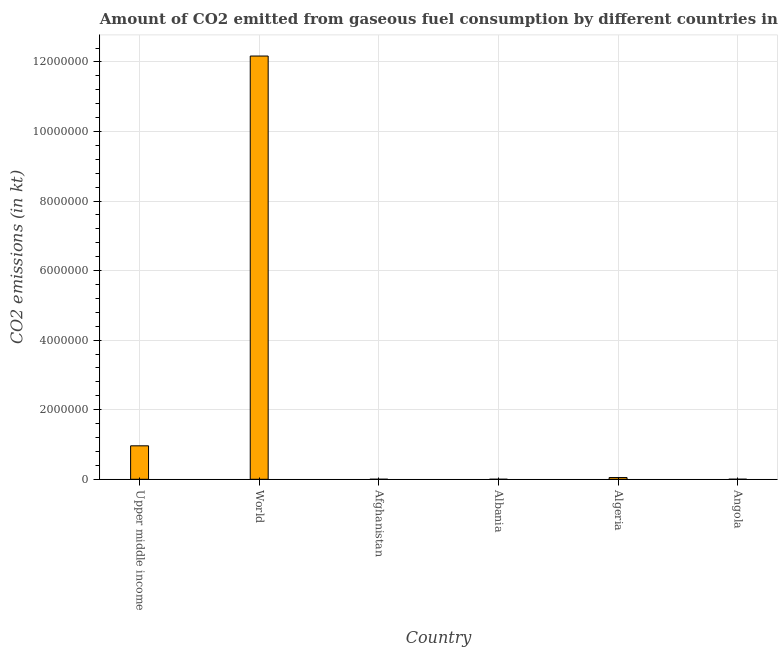Does the graph contain any zero values?
Keep it short and to the point. No. What is the title of the graph?
Provide a succinct answer. Amount of CO2 emitted from gaseous fuel consumption by different countries in 2006. What is the label or title of the X-axis?
Make the answer very short. Country. What is the label or title of the Y-axis?
Your answer should be compact. CO2 emissions (in kt). What is the co2 emissions from gaseous fuel consumption in Albania?
Make the answer very short. 22. Across all countries, what is the maximum co2 emissions from gaseous fuel consumption?
Your answer should be compact. 1.22e+07. Across all countries, what is the minimum co2 emissions from gaseous fuel consumption?
Keep it short and to the point. 22. In which country was the co2 emissions from gaseous fuel consumption maximum?
Provide a succinct answer. World. In which country was the co2 emissions from gaseous fuel consumption minimum?
Your response must be concise. Albania. What is the sum of the co2 emissions from gaseous fuel consumption?
Offer a terse response. 1.32e+07. What is the difference between the co2 emissions from gaseous fuel consumption in Angola and World?
Keep it short and to the point. -1.22e+07. What is the average co2 emissions from gaseous fuel consumption per country?
Offer a very short reply. 2.20e+06. What is the median co2 emissions from gaseous fuel consumption?
Offer a terse response. 2.53e+04. Is the co2 emissions from gaseous fuel consumption in Afghanistan less than that in Angola?
Provide a succinct answer. Yes. What is the difference between the highest and the second highest co2 emissions from gaseous fuel consumption?
Make the answer very short. 1.12e+07. What is the difference between the highest and the lowest co2 emissions from gaseous fuel consumption?
Offer a terse response. 1.22e+07. Are all the bars in the graph horizontal?
Your response must be concise. No. What is the CO2 emissions (in kt) of Upper middle income?
Your answer should be compact. 9.62e+05. What is the CO2 emissions (in kt) in World?
Provide a short and direct response. 1.22e+07. What is the CO2 emissions (in kt) of Afghanistan?
Your response must be concise. 330.03. What is the CO2 emissions (in kt) in Albania?
Keep it short and to the point. 22. What is the CO2 emissions (in kt) of Algeria?
Make the answer very short. 4.94e+04. What is the CO2 emissions (in kt) of Angola?
Your answer should be compact. 1305.45. What is the difference between the CO2 emissions (in kt) in Upper middle income and World?
Offer a terse response. -1.12e+07. What is the difference between the CO2 emissions (in kt) in Upper middle income and Afghanistan?
Offer a terse response. 9.62e+05. What is the difference between the CO2 emissions (in kt) in Upper middle income and Albania?
Ensure brevity in your answer.  9.62e+05. What is the difference between the CO2 emissions (in kt) in Upper middle income and Algeria?
Provide a succinct answer. 9.13e+05. What is the difference between the CO2 emissions (in kt) in Upper middle income and Angola?
Your response must be concise. 9.61e+05. What is the difference between the CO2 emissions (in kt) in World and Afghanistan?
Offer a very short reply. 1.22e+07. What is the difference between the CO2 emissions (in kt) in World and Albania?
Offer a terse response. 1.22e+07. What is the difference between the CO2 emissions (in kt) in World and Algeria?
Make the answer very short. 1.21e+07. What is the difference between the CO2 emissions (in kt) in World and Angola?
Offer a terse response. 1.22e+07. What is the difference between the CO2 emissions (in kt) in Afghanistan and Albania?
Your response must be concise. 308.03. What is the difference between the CO2 emissions (in kt) in Afghanistan and Algeria?
Offer a very short reply. -4.90e+04. What is the difference between the CO2 emissions (in kt) in Afghanistan and Angola?
Your response must be concise. -975.42. What is the difference between the CO2 emissions (in kt) in Albania and Algeria?
Keep it short and to the point. -4.93e+04. What is the difference between the CO2 emissions (in kt) in Albania and Angola?
Keep it short and to the point. -1283.45. What is the difference between the CO2 emissions (in kt) in Algeria and Angola?
Provide a succinct answer. 4.80e+04. What is the ratio of the CO2 emissions (in kt) in Upper middle income to that in World?
Offer a terse response. 0.08. What is the ratio of the CO2 emissions (in kt) in Upper middle income to that in Afghanistan?
Your answer should be compact. 2915.38. What is the ratio of the CO2 emissions (in kt) in Upper middle income to that in Albania?
Make the answer very short. 4.37e+04. What is the ratio of the CO2 emissions (in kt) in Upper middle income to that in Algeria?
Offer a very short reply. 19.5. What is the ratio of the CO2 emissions (in kt) in Upper middle income to that in Angola?
Provide a short and direct response. 737.03. What is the ratio of the CO2 emissions (in kt) in World to that in Afghanistan?
Your response must be concise. 3.69e+04. What is the ratio of the CO2 emissions (in kt) in World to that in Albania?
Give a very brief answer. 5.53e+05. What is the ratio of the CO2 emissions (in kt) in World to that in Algeria?
Give a very brief answer. 246.6. What is the ratio of the CO2 emissions (in kt) in World to that in Angola?
Your response must be concise. 9323.03. What is the ratio of the CO2 emissions (in kt) in Afghanistan to that in Algeria?
Ensure brevity in your answer.  0.01. What is the ratio of the CO2 emissions (in kt) in Afghanistan to that in Angola?
Keep it short and to the point. 0.25. What is the ratio of the CO2 emissions (in kt) in Albania to that in Angola?
Your response must be concise. 0.02. What is the ratio of the CO2 emissions (in kt) in Algeria to that in Angola?
Make the answer very short. 37.81. 